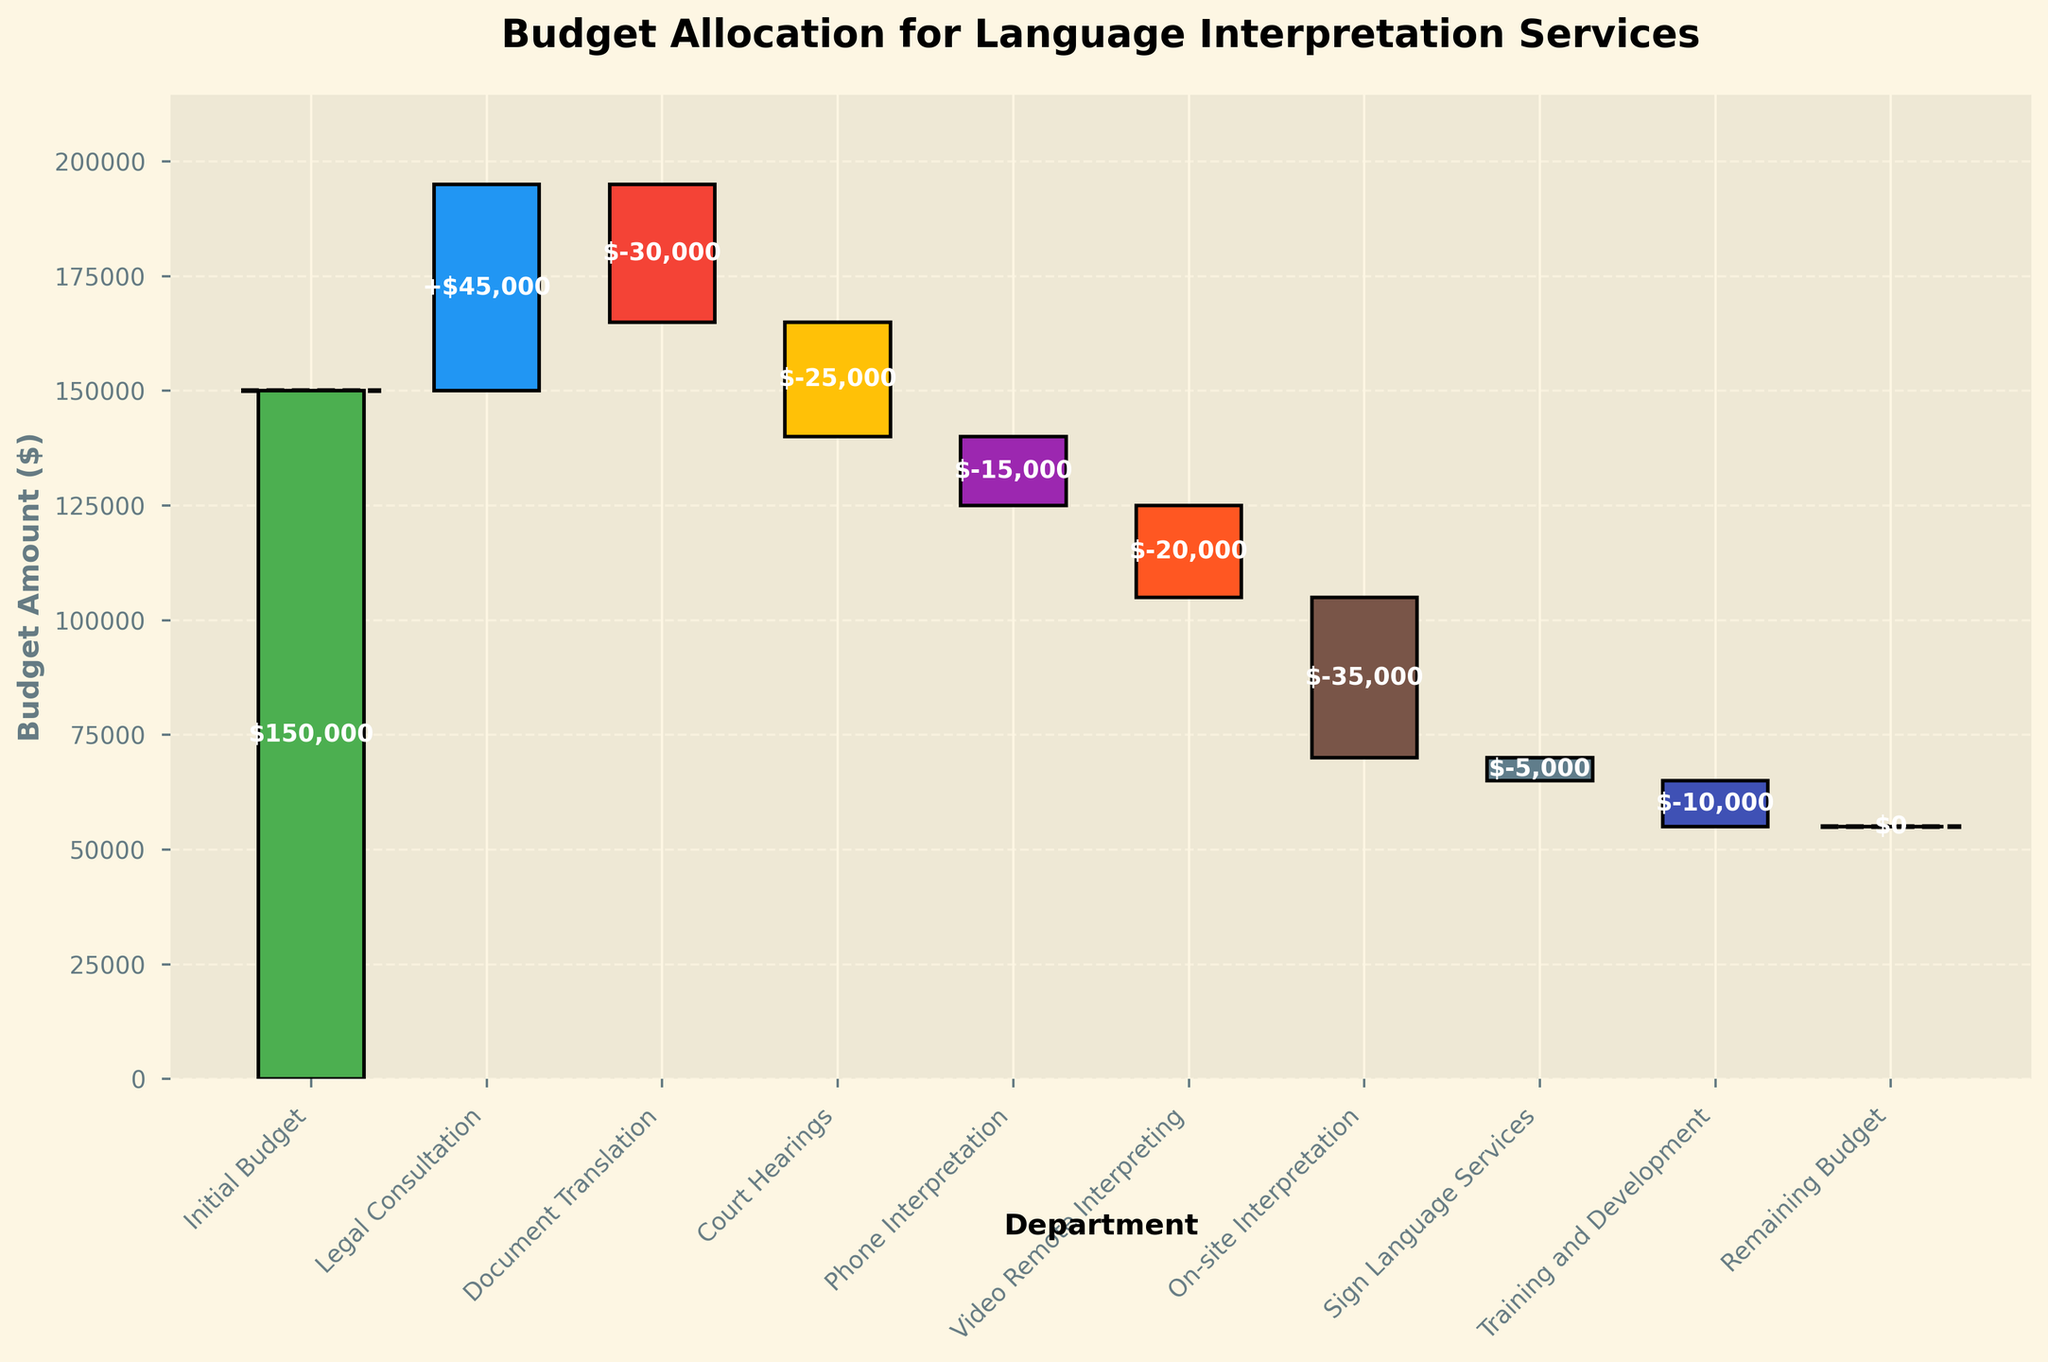What is the total initial budget allocation? The initial budget allocation is displayed as the first bar in the waterfall chart. It shows a value of $150,000.
Answer: $150,000 Which department has the highest budget allocation? The department with the highest budget allocation can be identified by the tallest positive bar in the chart. The "Legal Consultation" department has the highest allocation of $45,000.
Answer: Legal Consultation How much is allocated to Document Translation? Document Translation is represented by a negative bar in the chart, showing a value of -$30,000.
Answer: -$30,000 What is the total budget spent on interpretations excluding the initial budget and remaining budget? Sum all the values except "Initial Budget" and "Remaining Budget": 45,000 + (-30,000) + (-25,000) + (-15,000) + (-20,000) + (-35,000) + (-5,000) + (-10,000) = -90,000
Answer: -$90,000 Which two departments together contribute the most to the decrease in the budget? To find the departments contributing the most to the decrease, look for the two departments with the largest negative values. "On-site Interpretation" (-$35,000) and "Document Translation" (-$30,000) have the largest negative contributions.
Answer: On-site Interpretation and Document Translation How does the budget allocation for Phone Interpretation compare to Video Remote Interpreting? Compare the heights of the negative bars for both services. Phone Interpretation has -$15,000, and Video Remote Interpreting has -$20,000. Video Remote Interpreting has a larger negative allocation.
Answer: Video Remote Interpreting has a larger negative allocation What is the remaining budget after all allocations? The remaining budget is directly shown at the end of the chart, marked as $0.
Answer: $0 What total amount is allocated to interpreting services provided over the phone and video? Sum the allocations for Phone Interpretation and Video Remote Interpreting: -$15,000 + -$20,000 = -$35,000.
Answer: -$35,000 Which department's allocation results in the smallest decrease in the budget? Identify the department with the smallest negative value. Sign Language Services has the smallest decrease with -$5,000.
Answer: Sign Language Services If the initial budget was increased to $200,000, what would be the new remaining budget, assuming all other allocations remain the same? The initial budget increase means the new budget allocations: Initial Budget: $200,000, Legal Consultation: +$45,000, Document Translation: -$30,000, Court Hearings: -$25,000, Phone Interpretation: -$15,000, Video Remote Interpreting: -$20,000, On-site Interpretation: -$35,000, Sign Language Services: -$5,000, Training and Development: -$10,000. Sum these values: $200,000 + $45,000 - $30,000 - $25,000 - $15,000 - $20,000 - $35,000 - $5,000 - $10,000 = $105,000.
Answer: $105,000 